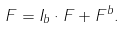<formula> <loc_0><loc_0><loc_500><loc_500>F = I _ { b } \cdot F + F ^ { b } .</formula> 